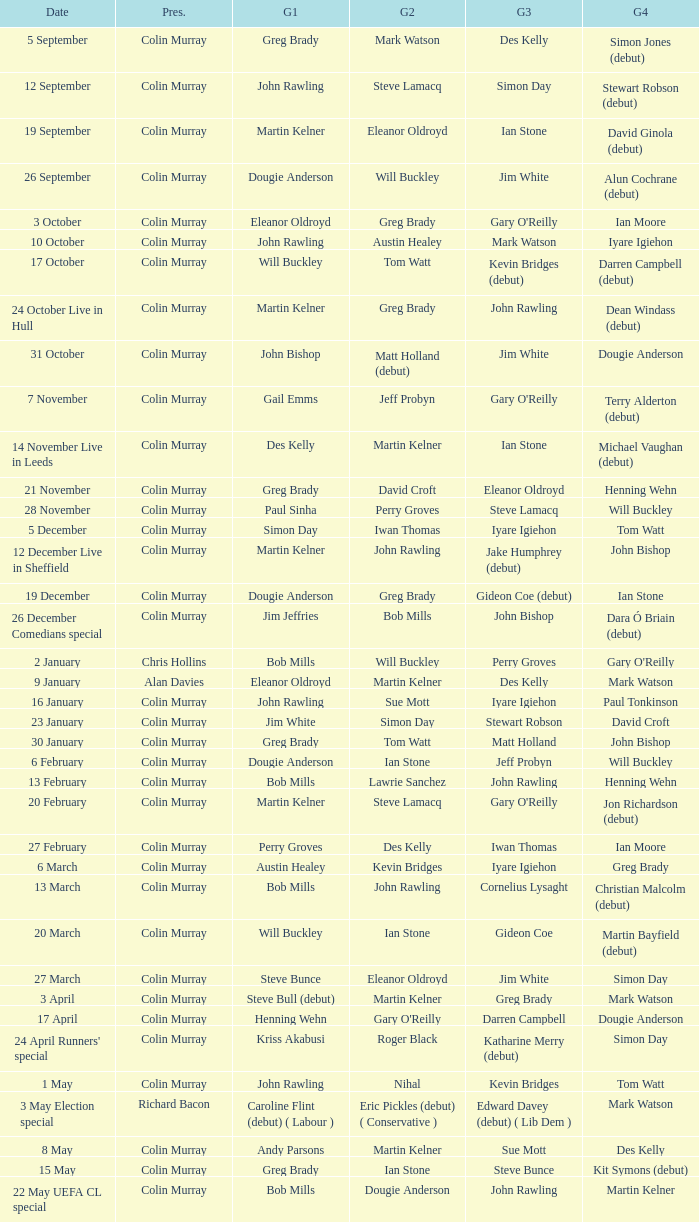On episodes where guest 1 is Jim White, who was guest 3? Stewart Robson. 